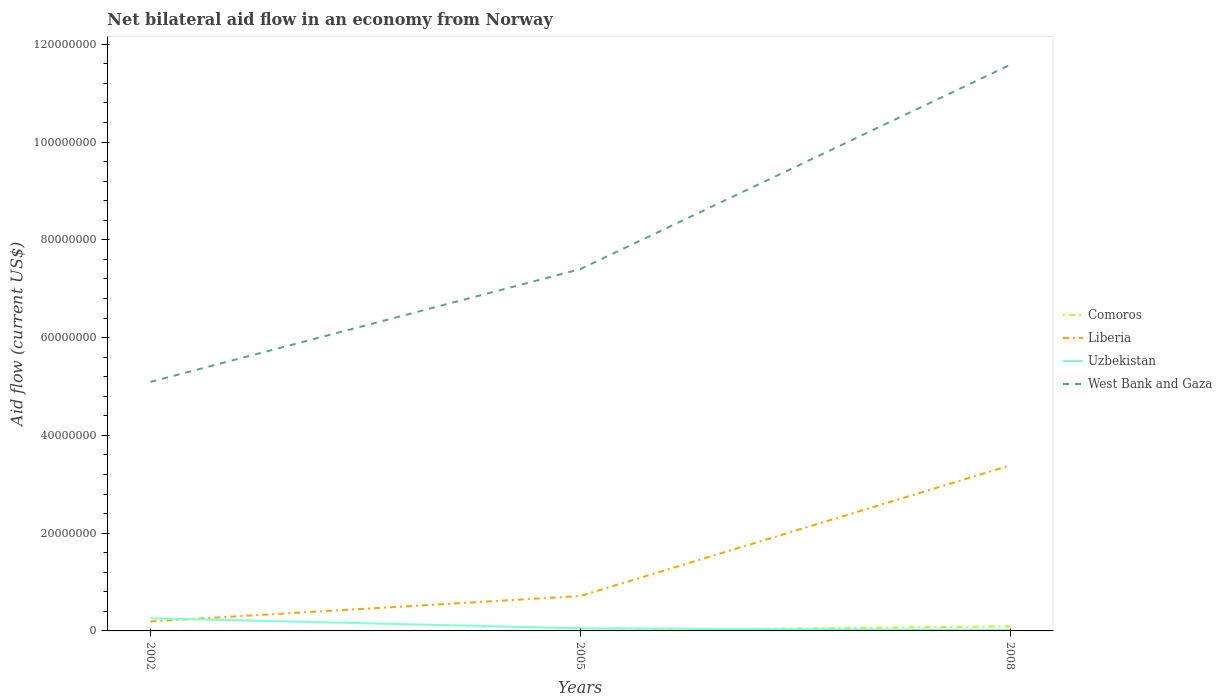Is the number of lines equal to the number of legend labels?
Provide a succinct answer. Yes. Across all years, what is the maximum net bilateral aid flow in Uzbekistan?
Give a very brief answer. 1.70e+05. In which year was the net bilateral aid flow in West Bank and Gaza maximum?
Your answer should be compact. 2002. What is the total net bilateral aid flow in Comoros in the graph?
Offer a very short reply. -9.10e+05. What is the difference between the highest and the second highest net bilateral aid flow in Uzbekistan?
Provide a short and direct response. 2.42e+06. Are the values on the major ticks of Y-axis written in scientific E-notation?
Your response must be concise. No. Does the graph contain grids?
Provide a short and direct response. No. How are the legend labels stacked?
Offer a very short reply. Vertical. What is the title of the graph?
Give a very brief answer. Net bilateral aid flow in an economy from Norway. Does "Macedonia" appear as one of the legend labels in the graph?
Ensure brevity in your answer.  No. What is the label or title of the X-axis?
Provide a short and direct response. Years. What is the Aid flow (current US$) of Liberia in 2002?
Give a very brief answer. 1.94e+06. What is the Aid flow (current US$) in Uzbekistan in 2002?
Your answer should be very brief. 2.59e+06. What is the Aid flow (current US$) of West Bank and Gaza in 2002?
Offer a very short reply. 5.09e+07. What is the Aid flow (current US$) of Comoros in 2005?
Your answer should be very brief. 3.00e+04. What is the Aid flow (current US$) in Liberia in 2005?
Offer a terse response. 7.14e+06. What is the Aid flow (current US$) in Uzbekistan in 2005?
Make the answer very short. 5.30e+05. What is the Aid flow (current US$) in West Bank and Gaza in 2005?
Provide a short and direct response. 7.40e+07. What is the Aid flow (current US$) of Comoros in 2008?
Keep it short and to the point. 9.40e+05. What is the Aid flow (current US$) in Liberia in 2008?
Your response must be concise. 3.38e+07. What is the Aid flow (current US$) of West Bank and Gaza in 2008?
Provide a short and direct response. 1.16e+08. Across all years, what is the maximum Aid flow (current US$) of Comoros?
Give a very brief answer. 9.40e+05. Across all years, what is the maximum Aid flow (current US$) of Liberia?
Your answer should be very brief. 3.38e+07. Across all years, what is the maximum Aid flow (current US$) of Uzbekistan?
Your response must be concise. 2.59e+06. Across all years, what is the maximum Aid flow (current US$) in West Bank and Gaza?
Offer a very short reply. 1.16e+08. Across all years, what is the minimum Aid flow (current US$) in Comoros?
Your answer should be compact. 2.00e+04. Across all years, what is the minimum Aid flow (current US$) of Liberia?
Provide a short and direct response. 1.94e+06. Across all years, what is the minimum Aid flow (current US$) in Uzbekistan?
Your response must be concise. 1.70e+05. Across all years, what is the minimum Aid flow (current US$) of West Bank and Gaza?
Your answer should be very brief. 5.09e+07. What is the total Aid flow (current US$) of Comoros in the graph?
Provide a succinct answer. 9.90e+05. What is the total Aid flow (current US$) in Liberia in the graph?
Provide a succinct answer. 4.29e+07. What is the total Aid flow (current US$) of Uzbekistan in the graph?
Offer a very short reply. 3.29e+06. What is the total Aid flow (current US$) of West Bank and Gaza in the graph?
Your response must be concise. 2.41e+08. What is the difference between the Aid flow (current US$) in Liberia in 2002 and that in 2005?
Ensure brevity in your answer.  -5.20e+06. What is the difference between the Aid flow (current US$) in Uzbekistan in 2002 and that in 2005?
Offer a very short reply. 2.06e+06. What is the difference between the Aid flow (current US$) of West Bank and Gaza in 2002 and that in 2005?
Ensure brevity in your answer.  -2.31e+07. What is the difference between the Aid flow (current US$) in Comoros in 2002 and that in 2008?
Offer a terse response. -9.20e+05. What is the difference between the Aid flow (current US$) of Liberia in 2002 and that in 2008?
Keep it short and to the point. -3.19e+07. What is the difference between the Aid flow (current US$) of Uzbekistan in 2002 and that in 2008?
Provide a short and direct response. 2.42e+06. What is the difference between the Aid flow (current US$) of West Bank and Gaza in 2002 and that in 2008?
Keep it short and to the point. -6.48e+07. What is the difference between the Aid flow (current US$) in Comoros in 2005 and that in 2008?
Make the answer very short. -9.10e+05. What is the difference between the Aid flow (current US$) in Liberia in 2005 and that in 2008?
Give a very brief answer. -2.67e+07. What is the difference between the Aid flow (current US$) of Uzbekistan in 2005 and that in 2008?
Give a very brief answer. 3.60e+05. What is the difference between the Aid flow (current US$) of West Bank and Gaza in 2005 and that in 2008?
Give a very brief answer. -4.18e+07. What is the difference between the Aid flow (current US$) in Comoros in 2002 and the Aid flow (current US$) in Liberia in 2005?
Offer a very short reply. -7.12e+06. What is the difference between the Aid flow (current US$) of Comoros in 2002 and the Aid flow (current US$) of Uzbekistan in 2005?
Offer a very short reply. -5.10e+05. What is the difference between the Aid flow (current US$) in Comoros in 2002 and the Aid flow (current US$) in West Bank and Gaza in 2005?
Offer a terse response. -7.40e+07. What is the difference between the Aid flow (current US$) in Liberia in 2002 and the Aid flow (current US$) in Uzbekistan in 2005?
Offer a very short reply. 1.41e+06. What is the difference between the Aid flow (current US$) of Liberia in 2002 and the Aid flow (current US$) of West Bank and Gaza in 2005?
Your response must be concise. -7.21e+07. What is the difference between the Aid flow (current US$) in Uzbekistan in 2002 and the Aid flow (current US$) in West Bank and Gaza in 2005?
Provide a short and direct response. -7.14e+07. What is the difference between the Aid flow (current US$) of Comoros in 2002 and the Aid flow (current US$) of Liberia in 2008?
Make the answer very short. -3.38e+07. What is the difference between the Aid flow (current US$) in Comoros in 2002 and the Aid flow (current US$) in Uzbekistan in 2008?
Keep it short and to the point. -1.50e+05. What is the difference between the Aid flow (current US$) of Comoros in 2002 and the Aid flow (current US$) of West Bank and Gaza in 2008?
Make the answer very short. -1.16e+08. What is the difference between the Aid flow (current US$) of Liberia in 2002 and the Aid flow (current US$) of Uzbekistan in 2008?
Your response must be concise. 1.77e+06. What is the difference between the Aid flow (current US$) of Liberia in 2002 and the Aid flow (current US$) of West Bank and Gaza in 2008?
Your response must be concise. -1.14e+08. What is the difference between the Aid flow (current US$) in Uzbekistan in 2002 and the Aid flow (current US$) in West Bank and Gaza in 2008?
Your response must be concise. -1.13e+08. What is the difference between the Aid flow (current US$) of Comoros in 2005 and the Aid flow (current US$) of Liberia in 2008?
Offer a terse response. -3.38e+07. What is the difference between the Aid flow (current US$) of Comoros in 2005 and the Aid flow (current US$) of West Bank and Gaza in 2008?
Offer a terse response. -1.16e+08. What is the difference between the Aid flow (current US$) in Liberia in 2005 and the Aid flow (current US$) in Uzbekistan in 2008?
Your answer should be compact. 6.97e+06. What is the difference between the Aid flow (current US$) in Liberia in 2005 and the Aid flow (current US$) in West Bank and Gaza in 2008?
Offer a terse response. -1.09e+08. What is the difference between the Aid flow (current US$) of Uzbekistan in 2005 and the Aid flow (current US$) of West Bank and Gaza in 2008?
Provide a short and direct response. -1.15e+08. What is the average Aid flow (current US$) in Comoros per year?
Your answer should be compact. 3.30e+05. What is the average Aid flow (current US$) in Liberia per year?
Your response must be concise. 1.43e+07. What is the average Aid flow (current US$) of Uzbekistan per year?
Provide a succinct answer. 1.10e+06. What is the average Aid flow (current US$) of West Bank and Gaza per year?
Your answer should be very brief. 8.02e+07. In the year 2002, what is the difference between the Aid flow (current US$) of Comoros and Aid flow (current US$) of Liberia?
Keep it short and to the point. -1.92e+06. In the year 2002, what is the difference between the Aid flow (current US$) in Comoros and Aid flow (current US$) in Uzbekistan?
Your answer should be compact. -2.57e+06. In the year 2002, what is the difference between the Aid flow (current US$) in Comoros and Aid flow (current US$) in West Bank and Gaza?
Ensure brevity in your answer.  -5.09e+07. In the year 2002, what is the difference between the Aid flow (current US$) of Liberia and Aid flow (current US$) of Uzbekistan?
Give a very brief answer. -6.50e+05. In the year 2002, what is the difference between the Aid flow (current US$) in Liberia and Aid flow (current US$) in West Bank and Gaza?
Offer a terse response. -4.90e+07. In the year 2002, what is the difference between the Aid flow (current US$) in Uzbekistan and Aid flow (current US$) in West Bank and Gaza?
Your response must be concise. -4.84e+07. In the year 2005, what is the difference between the Aid flow (current US$) in Comoros and Aid flow (current US$) in Liberia?
Your answer should be compact. -7.11e+06. In the year 2005, what is the difference between the Aid flow (current US$) of Comoros and Aid flow (current US$) of Uzbekistan?
Your answer should be very brief. -5.00e+05. In the year 2005, what is the difference between the Aid flow (current US$) in Comoros and Aid flow (current US$) in West Bank and Gaza?
Offer a very short reply. -7.40e+07. In the year 2005, what is the difference between the Aid flow (current US$) in Liberia and Aid flow (current US$) in Uzbekistan?
Give a very brief answer. 6.61e+06. In the year 2005, what is the difference between the Aid flow (current US$) of Liberia and Aid flow (current US$) of West Bank and Gaza?
Your answer should be very brief. -6.69e+07. In the year 2005, what is the difference between the Aid flow (current US$) in Uzbekistan and Aid flow (current US$) in West Bank and Gaza?
Provide a succinct answer. -7.35e+07. In the year 2008, what is the difference between the Aid flow (current US$) in Comoros and Aid flow (current US$) in Liberia?
Make the answer very short. -3.29e+07. In the year 2008, what is the difference between the Aid flow (current US$) in Comoros and Aid flow (current US$) in Uzbekistan?
Provide a succinct answer. 7.70e+05. In the year 2008, what is the difference between the Aid flow (current US$) in Comoros and Aid flow (current US$) in West Bank and Gaza?
Make the answer very short. -1.15e+08. In the year 2008, what is the difference between the Aid flow (current US$) in Liberia and Aid flow (current US$) in Uzbekistan?
Provide a succinct answer. 3.37e+07. In the year 2008, what is the difference between the Aid flow (current US$) of Liberia and Aid flow (current US$) of West Bank and Gaza?
Keep it short and to the point. -8.19e+07. In the year 2008, what is the difference between the Aid flow (current US$) of Uzbekistan and Aid flow (current US$) of West Bank and Gaza?
Keep it short and to the point. -1.16e+08. What is the ratio of the Aid flow (current US$) of Comoros in 2002 to that in 2005?
Make the answer very short. 0.67. What is the ratio of the Aid flow (current US$) of Liberia in 2002 to that in 2005?
Give a very brief answer. 0.27. What is the ratio of the Aid flow (current US$) in Uzbekistan in 2002 to that in 2005?
Your answer should be compact. 4.89. What is the ratio of the Aid flow (current US$) in West Bank and Gaza in 2002 to that in 2005?
Offer a terse response. 0.69. What is the ratio of the Aid flow (current US$) in Comoros in 2002 to that in 2008?
Make the answer very short. 0.02. What is the ratio of the Aid flow (current US$) of Liberia in 2002 to that in 2008?
Offer a terse response. 0.06. What is the ratio of the Aid flow (current US$) of Uzbekistan in 2002 to that in 2008?
Keep it short and to the point. 15.24. What is the ratio of the Aid flow (current US$) in West Bank and Gaza in 2002 to that in 2008?
Keep it short and to the point. 0.44. What is the ratio of the Aid flow (current US$) in Comoros in 2005 to that in 2008?
Offer a very short reply. 0.03. What is the ratio of the Aid flow (current US$) in Liberia in 2005 to that in 2008?
Give a very brief answer. 0.21. What is the ratio of the Aid flow (current US$) of Uzbekistan in 2005 to that in 2008?
Your answer should be compact. 3.12. What is the ratio of the Aid flow (current US$) in West Bank and Gaza in 2005 to that in 2008?
Your response must be concise. 0.64. What is the difference between the highest and the second highest Aid flow (current US$) in Comoros?
Offer a terse response. 9.10e+05. What is the difference between the highest and the second highest Aid flow (current US$) of Liberia?
Ensure brevity in your answer.  2.67e+07. What is the difference between the highest and the second highest Aid flow (current US$) in Uzbekistan?
Provide a short and direct response. 2.06e+06. What is the difference between the highest and the second highest Aid flow (current US$) of West Bank and Gaza?
Ensure brevity in your answer.  4.18e+07. What is the difference between the highest and the lowest Aid flow (current US$) of Comoros?
Make the answer very short. 9.20e+05. What is the difference between the highest and the lowest Aid flow (current US$) of Liberia?
Offer a terse response. 3.19e+07. What is the difference between the highest and the lowest Aid flow (current US$) in Uzbekistan?
Your answer should be very brief. 2.42e+06. What is the difference between the highest and the lowest Aid flow (current US$) of West Bank and Gaza?
Offer a very short reply. 6.48e+07. 